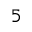<formula> <loc_0><loc_0><loc_500><loc_500>_ { 5 }</formula> 